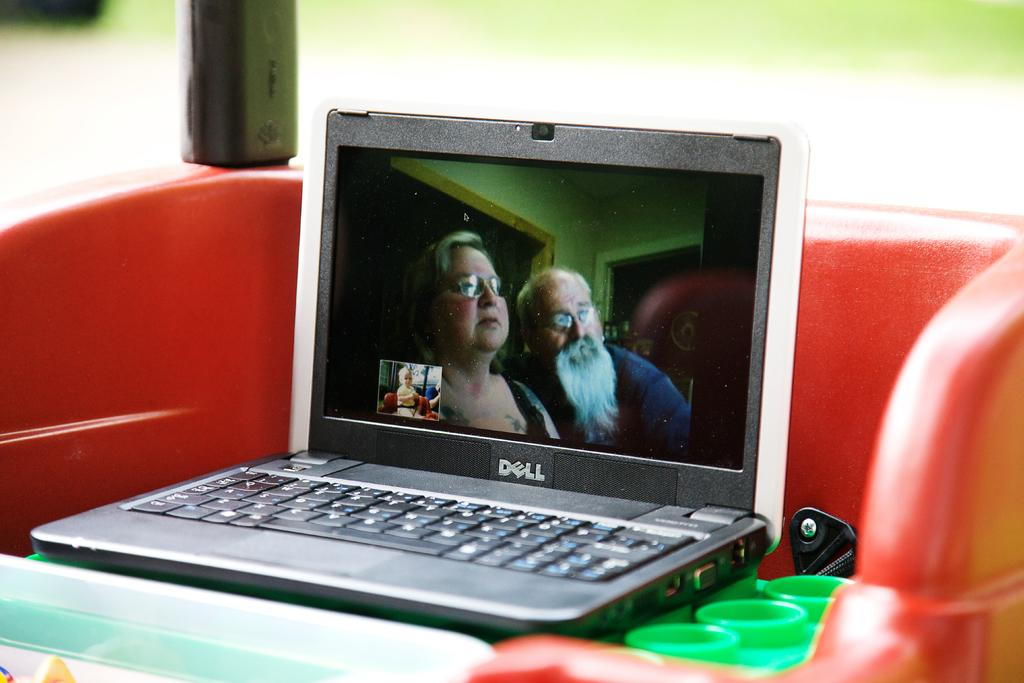<image>
Provide a brief description of the given image. A Dell laptop computer is displaying an image of an elderly man and woman. 